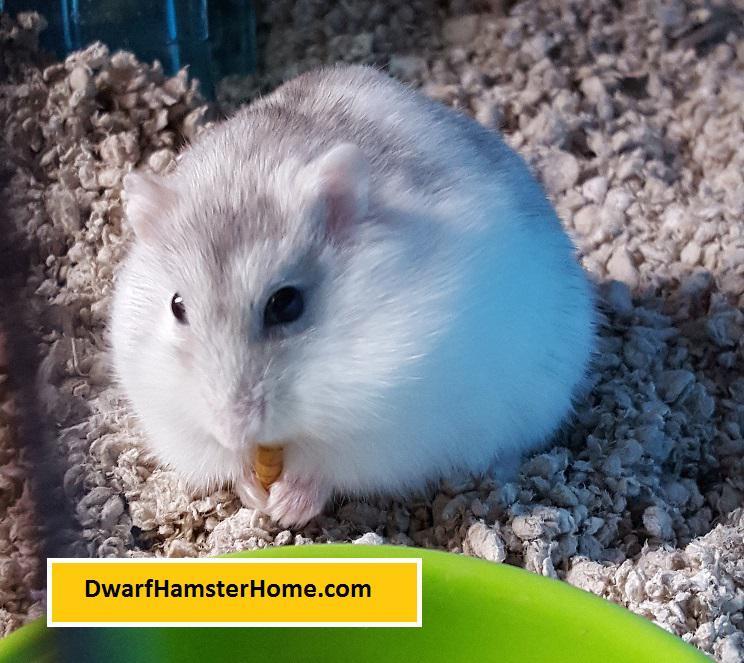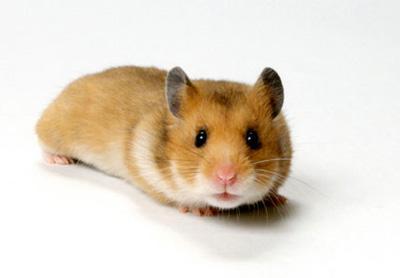The first image is the image on the left, the second image is the image on the right. Analyze the images presented: Is the assertion "All the rodents are sitting on a white surface." valid? Answer yes or no. No. 